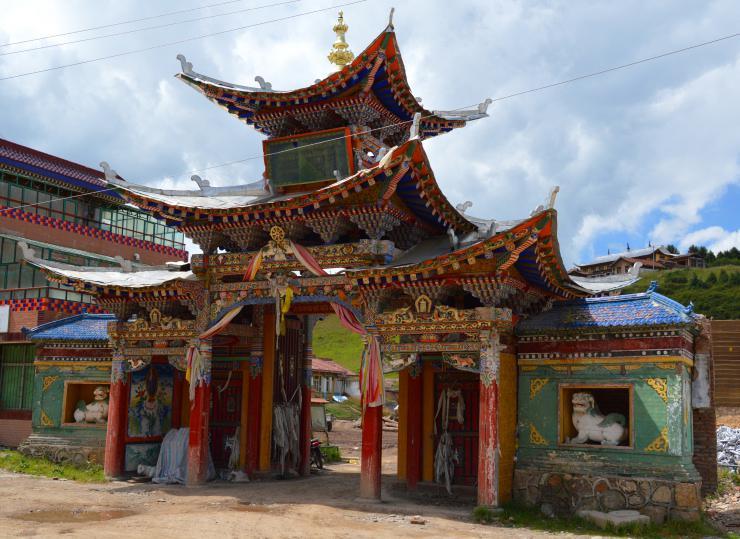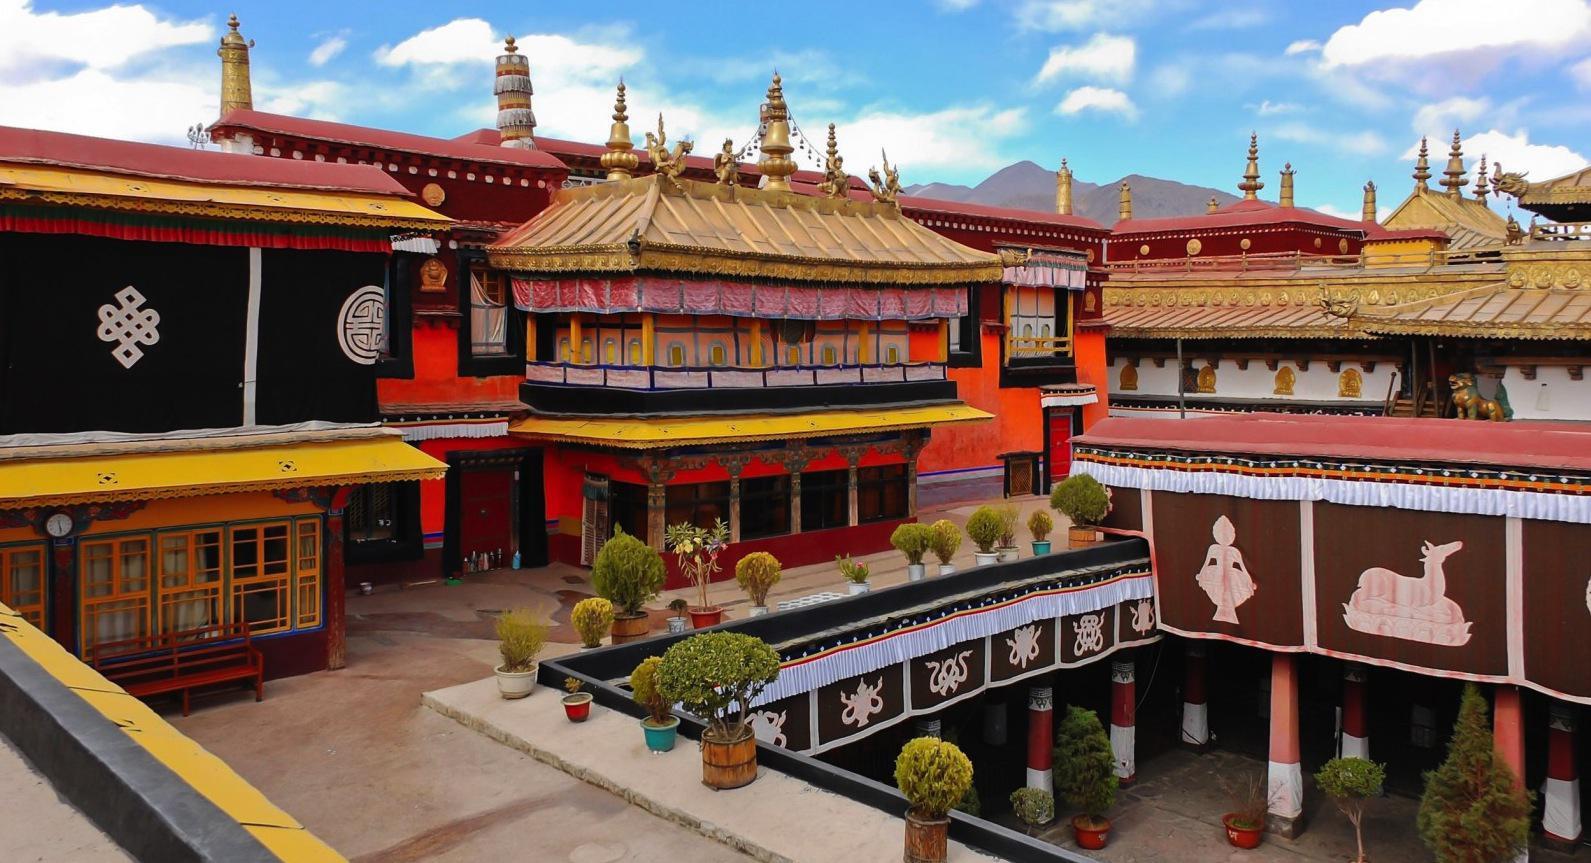The first image is the image on the left, the second image is the image on the right. Assess this claim about the two images: "An image shows a temple built in tiers that follow the shape of a side of a mountain.". Correct or not? Answer yes or no. No. 